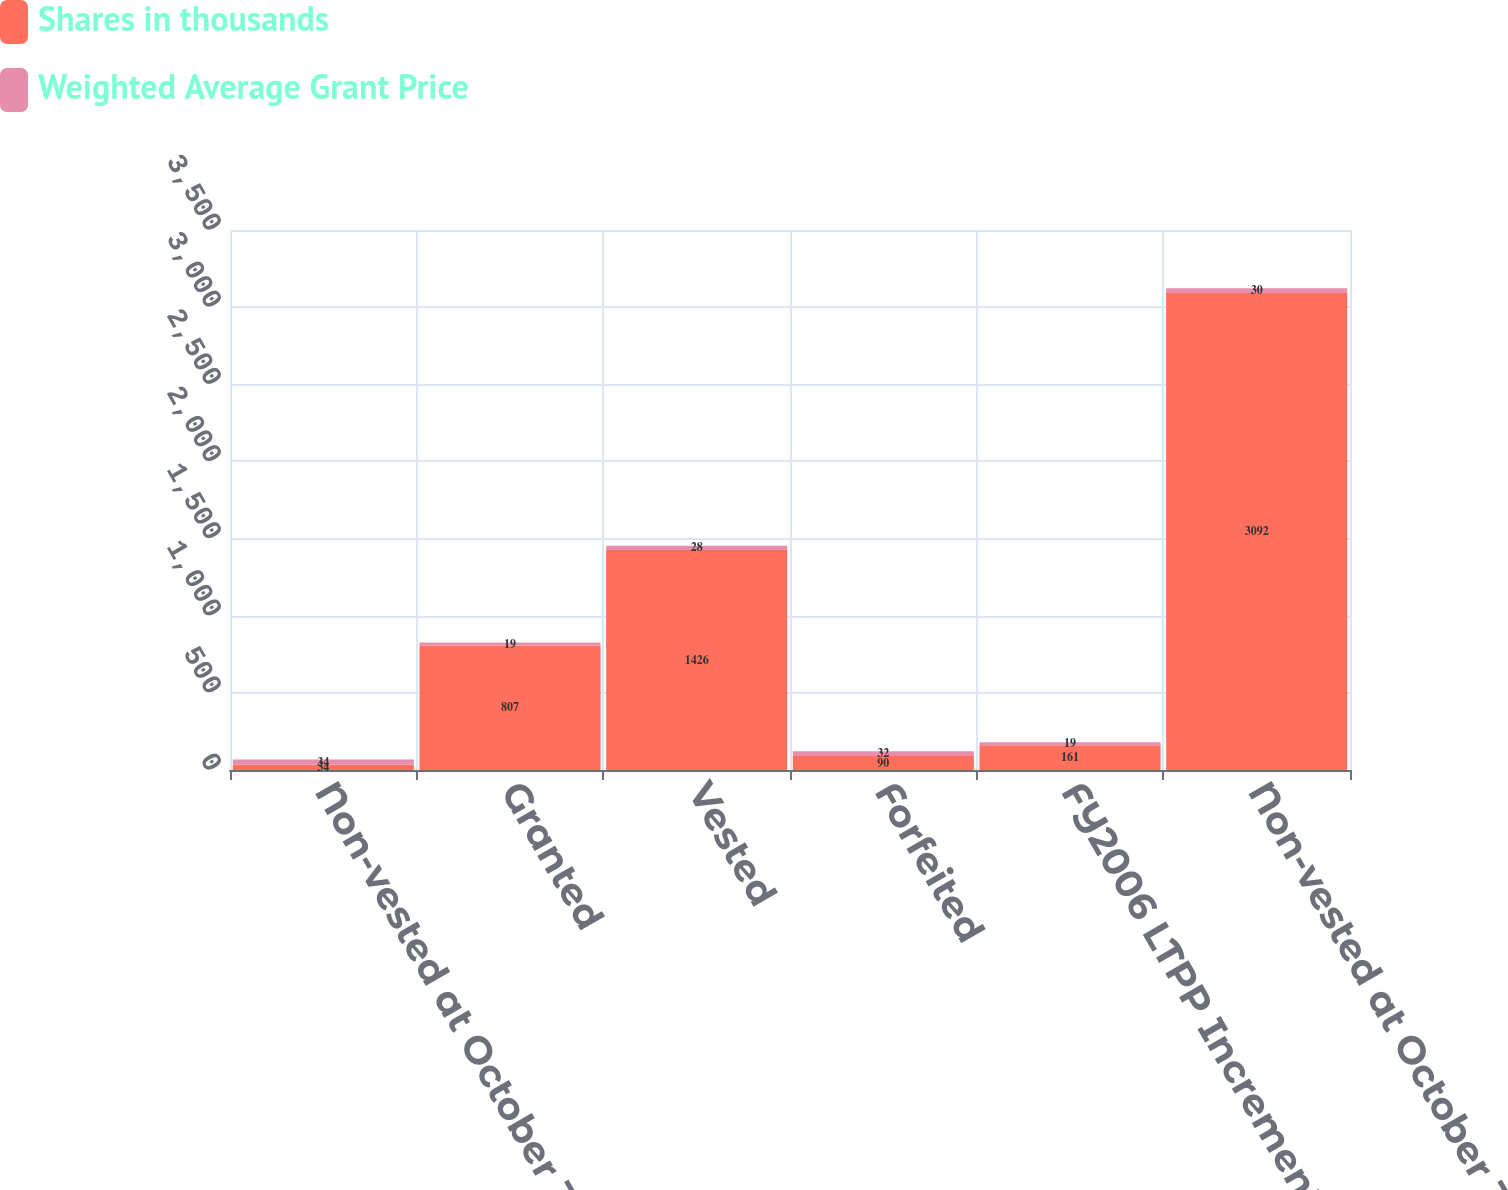<chart> <loc_0><loc_0><loc_500><loc_500><stacked_bar_chart><ecel><fcel>Non-vested at October 31 2008<fcel>Granted<fcel>Vested<fcel>Forfeited<fcel>FY2006 LTPP Incremental<fcel>Non-vested at October 31 2009<nl><fcel>Shares in thousands<fcel>34<fcel>807<fcel>1426<fcel>90<fcel>161<fcel>3092<nl><fcel>Weighted Average Grant Price<fcel>34<fcel>19<fcel>28<fcel>32<fcel>19<fcel>30<nl></chart> 